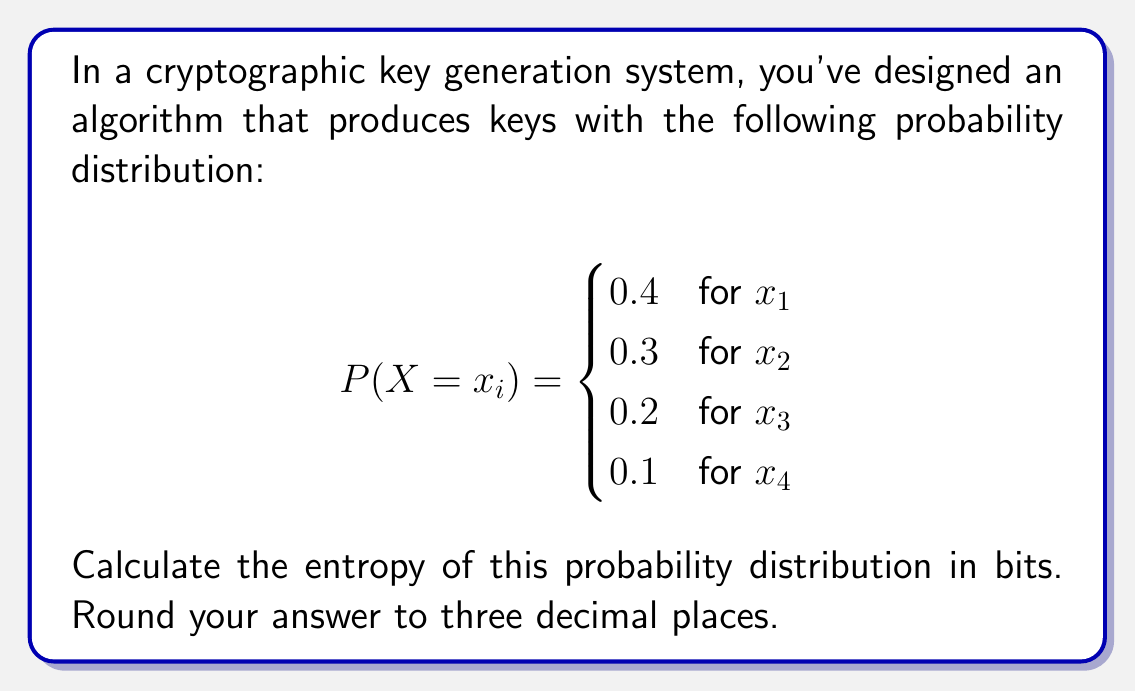Can you solve this math problem? To calculate the entropy of a probability distribution, we use the formula:

$$H(X) = -\sum_{i=1}^n P(x_i) \log_2 P(x_i)$$

where $P(x_i)$ is the probability of outcome $x_i$, and $n$ is the number of possible outcomes.

Let's calculate each term:

1. For $x_1$: $-0.4 \log_2(0.4)$
   $= -0.4 \times (-1.321928) = 0.528771$

2. For $x_2$: $-0.3 \log_2(0.3)$
   $= -0.3 \times (-1.736966) = 0.521090$

3. For $x_3$: $-0.2 \log_2(0.2)$
   $= -0.2 \times (-2.321928) = 0.464386$

4. For $x_4$: $-0.1 \log_2(0.1)$
   $= -0.1 \times (-3.321928) = 0.332193$

Now, we sum these values:

$$H(X) = 0.528771 + 0.521090 + 0.464386 + 0.332193 = 1.846440$$

Rounding to three decimal places, we get 1.846 bits.
Answer: 1.846 bits 